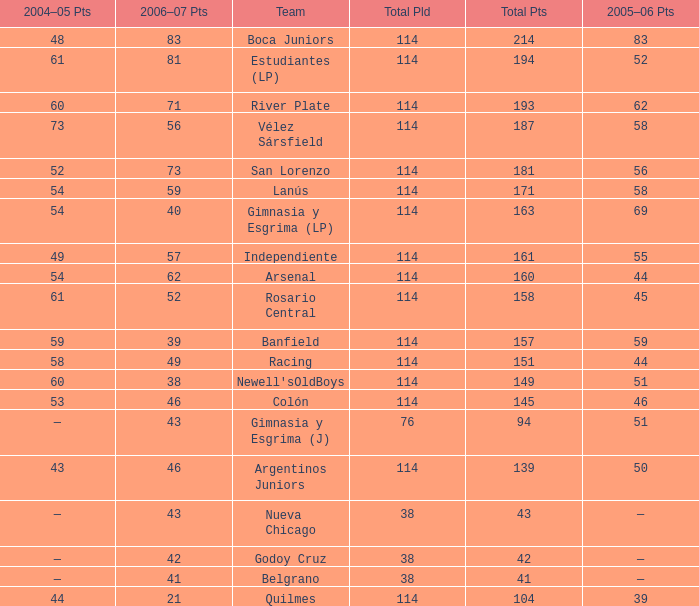I'm looking to parse the entire table for insights. Could you assist me with that? {'header': ['2004–05 Pts', '2006–07 Pts', 'Team', 'Total Pld', 'Total Pts', '2005–06 Pts'], 'rows': [['48', '83', 'Boca Juniors', '114', '214', '83'], ['61', '81', 'Estudiantes (LP)', '114', '194', '52'], ['60', '71', 'River Plate', '114', '193', '62'], ['73', '56', 'Vélez Sársfield', '114', '187', '58'], ['52', '73', 'San Lorenzo', '114', '181', '56'], ['54', '59', 'Lanús', '114', '171', '58'], ['54', '40', 'Gimnasia y Esgrima (LP)', '114', '163', '69'], ['49', '57', 'Independiente', '114', '161', '55'], ['54', '62', 'Arsenal', '114', '160', '44'], ['61', '52', 'Rosario Central', '114', '158', '45'], ['59', '39', 'Banfield', '114', '157', '59'], ['58', '49', 'Racing', '114', '151', '44'], ['60', '38', "Newell'sOldBoys", '114', '149', '51'], ['53', '46', 'Colón', '114', '145', '46'], ['—', '43', 'Gimnasia y Esgrima (J)', '76', '94', '51'], ['43', '46', 'Argentinos Juniors', '114', '139', '50'], ['—', '43', 'Nueva Chicago', '38', '43', '—'], ['—', '42', 'Godoy Cruz', '38', '42', '—'], ['—', '41', 'Belgrano', '38', '41', '—'], ['44', '21', 'Quilmes', '114', '104', '39']]} What is the total pld with 158 points in 2006-07, and less than 52 points in 2006-07? None. 